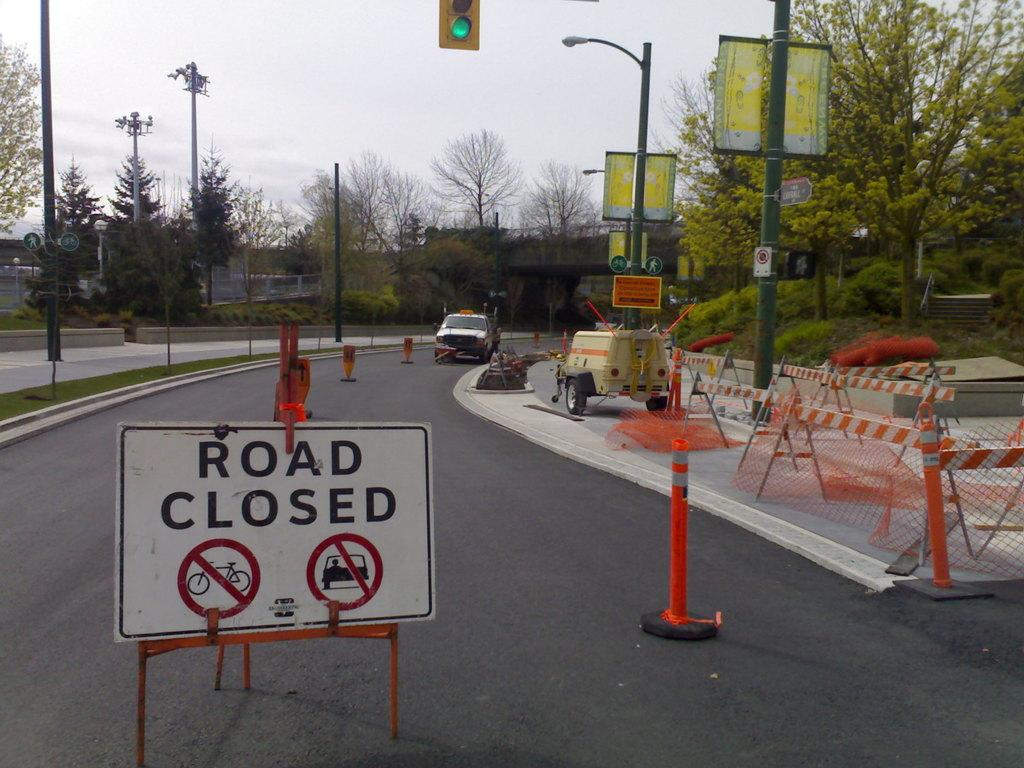Provide a one-sentence caption for the provided image. A road closed sign is in the foreground while items used for working on the road is in the background. 